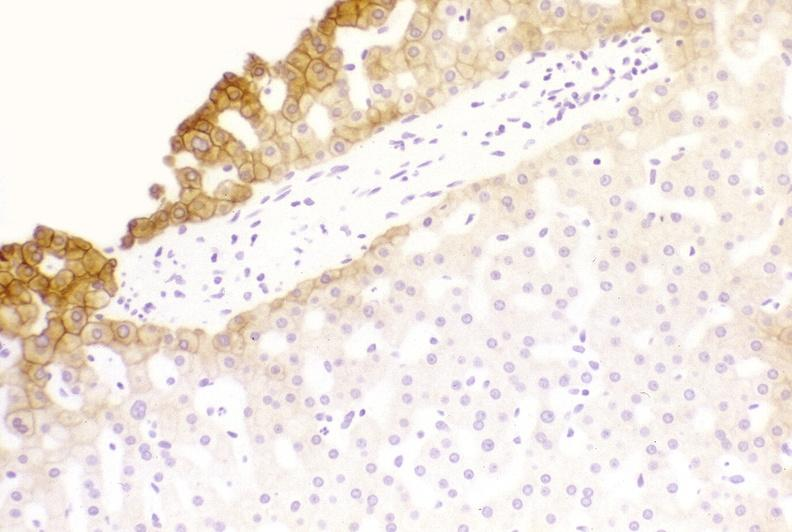s histiocyte present?
Answer the question using a single word or phrase. No 